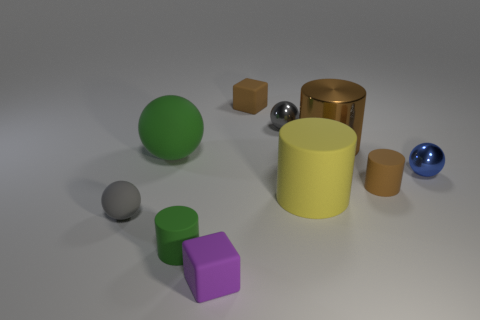Subtract all cylinders. How many objects are left? 6 Add 4 blue metal objects. How many blue metal objects exist? 5 Subtract 0 red cylinders. How many objects are left? 10 Subtract all matte balls. Subtract all large rubber things. How many objects are left? 6 Add 2 small gray metallic things. How many small gray metallic things are left? 3 